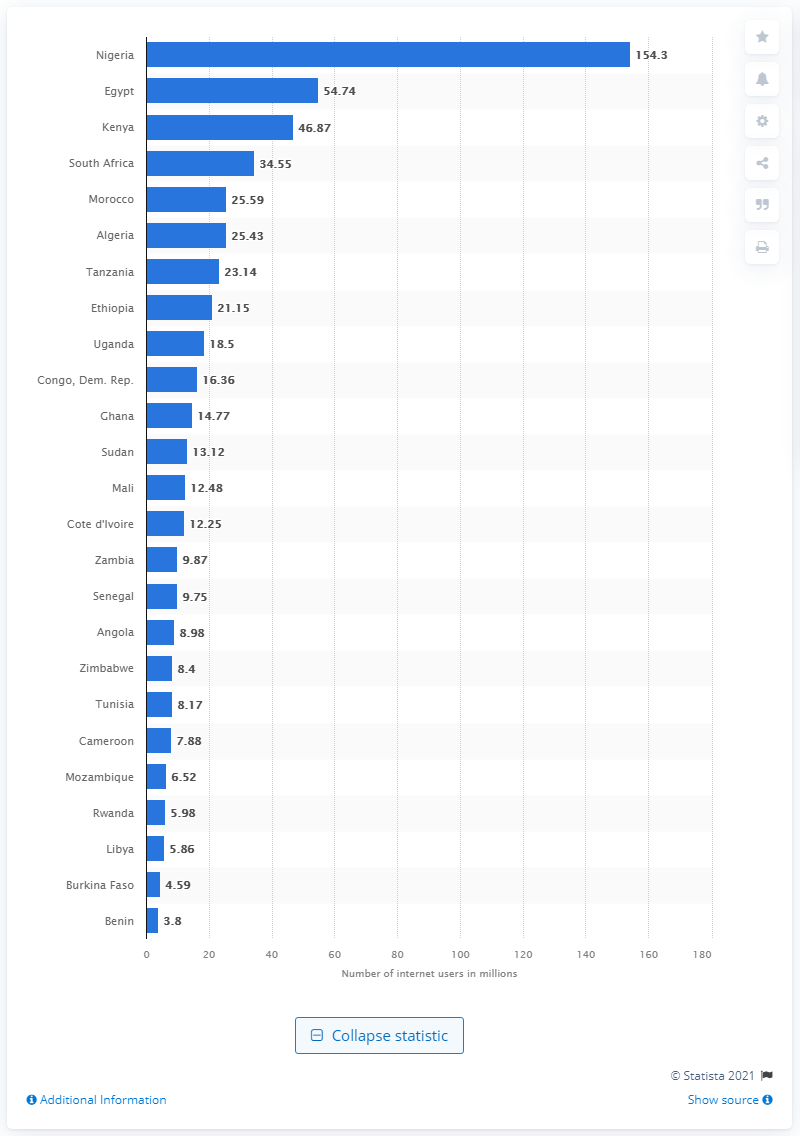List a handful of essential elements in this visual. As of December 2020, it is estimated that there were 154.3 million internet users in Nigeria. As of December 2020, Egypt had 54.74 million internet users. 